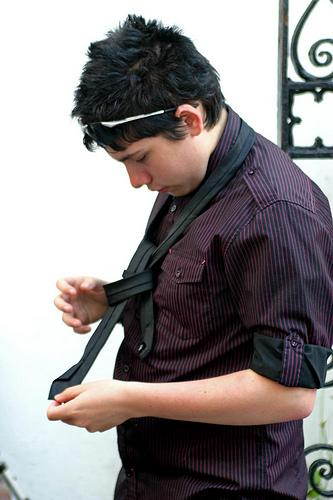What is the sentiment of the image based on the depicted activity? The sentiment of the image is concentrated, as the young man is focused on putting on a tie. What is the metal object in this image, and what is the color? The metal object is a black color steel grill structure. How many hands can be seen in the image, and what are they doing? There are two hands of a young man, and they are holding a black tie. Explain the young man's hairstyle and color. The young man has black hair with a slightly messy style. What is unique about the shirt the young man is wearing? The shirt is purple with a large pocket and a button-down collar, and it is striped. In the context of the image, how does the sleeve of the shirt look? The shirt sleeve is rolled up, revealing the man's arm. State the color and design of the man's shirt, including its special features. The man is wearing a black and purple striped formal button-down shirt with a large pocket and a collar. Identify the main object of this image and briefly describe its action. A well-dressed young man is trying to put on a black tie. Determine the type of sunglasses seen in this image and describe their appearance. The sunglasses are black and silver with a white frame, suggesting a stylish design. What is the color and style of the tie the man is holding? The tie is black and long, suggesting a formal style. 